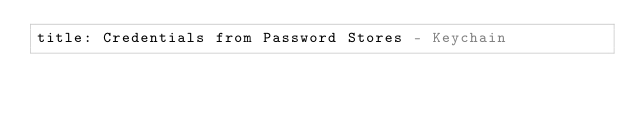<code> <loc_0><loc_0><loc_500><loc_500><_YAML_>title: Credentials from Password Stores - Keychain</code> 